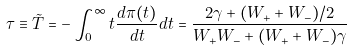Convert formula to latex. <formula><loc_0><loc_0><loc_500><loc_500>\tau \equiv \tilde { T } = - \int _ { 0 } ^ { \infty } t \frac { d \pi ( t ) } { d t } d t = \frac { 2 \gamma + ( W _ { + } + W _ { - } ) / 2 } { W _ { + } W _ { - } + ( W _ { + } + W _ { - } ) \gamma }</formula> 